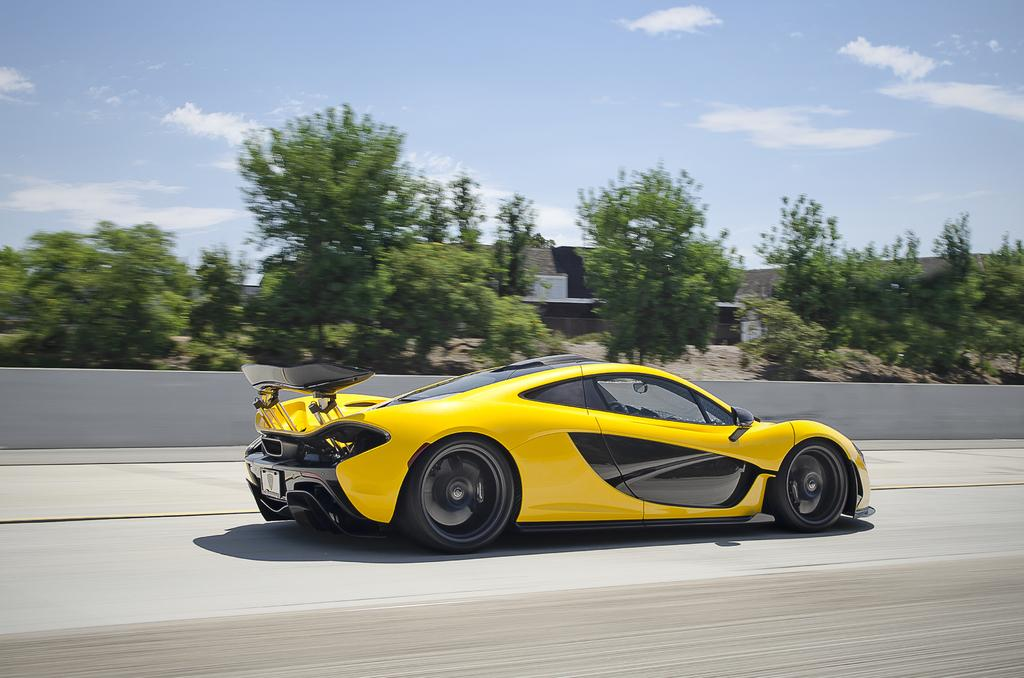What is the main subject in the center of the image? There is a car in the center of the image. What can be seen in the background of the image? There are trees, a wall, and other objects in the background of the image. What is at the bottom of the image? There is a road at the bottom of the image. What is visible at the top of the image? The sky is visible at the top of the image. Can you see the sea in the background of the image? No, there is no sea visible in the image. The background features trees, a wall, and other objects, but not the sea. 